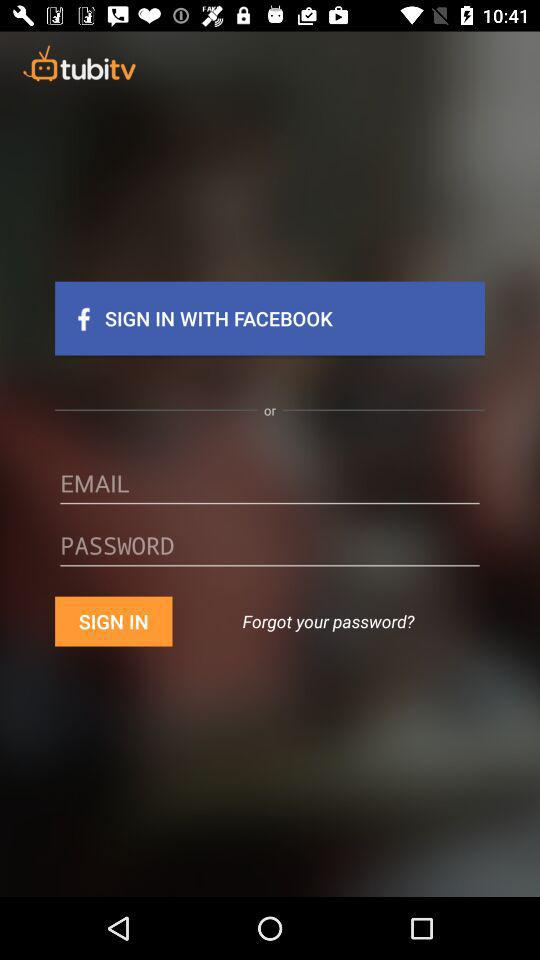What are the options for signing in? The options are "FACEBOOK" and "EMAIL". 